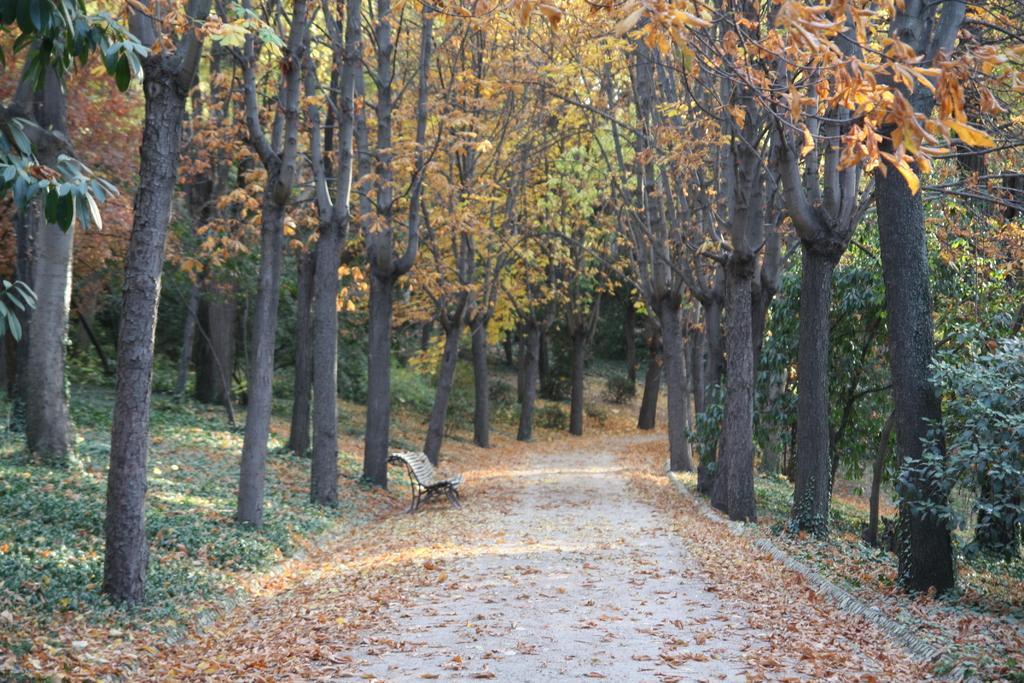Can you describe this image briefly? In this image I can see a bench in cream color, background I can see trees in green and brown color 